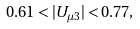<formula> <loc_0><loc_0><loc_500><loc_500>0 . 6 1 < | U _ { \mu 3 } | < 0 . 7 7 ,</formula> 